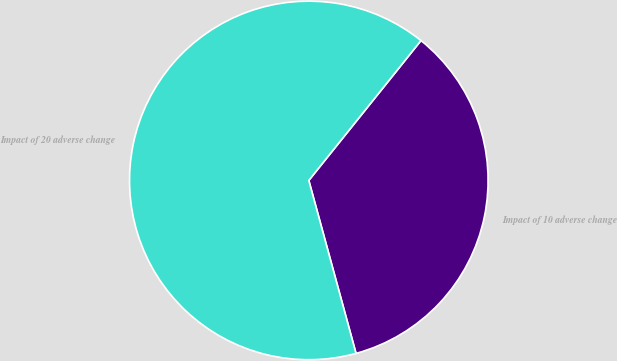Convert chart to OTSL. <chart><loc_0><loc_0><loc_500><loc_500><pie_chart><fcel>Impact of 10 adverse change<fcel>Impact of 20 adverse change<nl><fcel>35.0%<fcel>65.0%<nl></chart> 